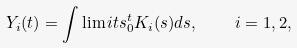Convert formula to latex. <formula><loc_0><loc_0><loc_500><loc_500>Y _ { i } ( t ) = \int \lim i t s _ { 0 } ^ { t } K _ { i } ( s ) d s , \quad i = 1 , 2 ,</formula> 